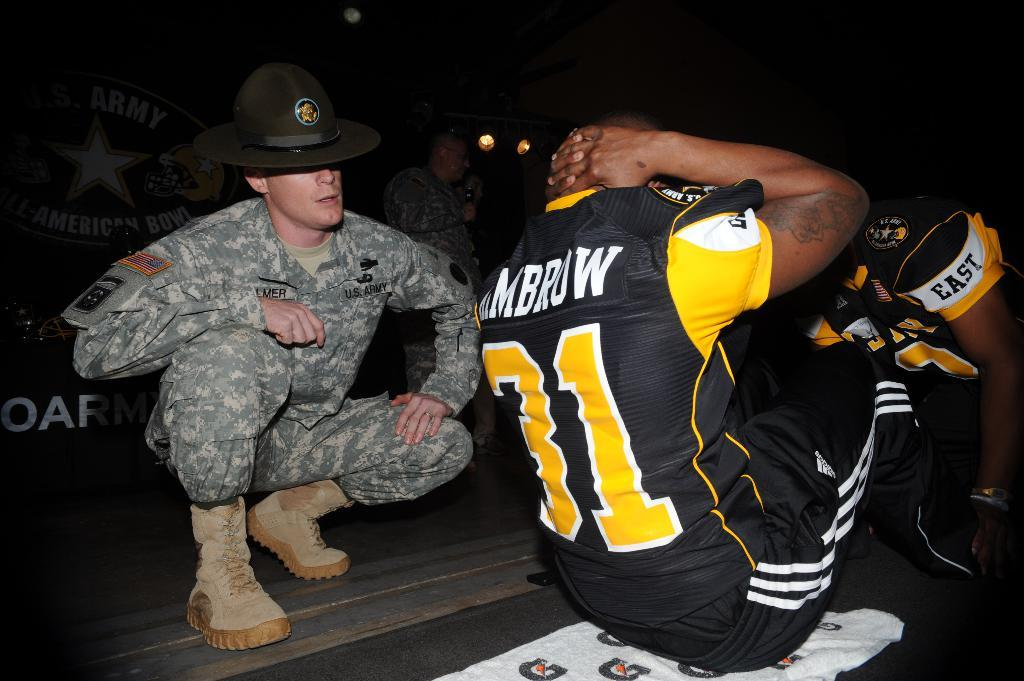Provide a one-sentence caption for the provided image. a man that is wearing the number 31 in yellow. 